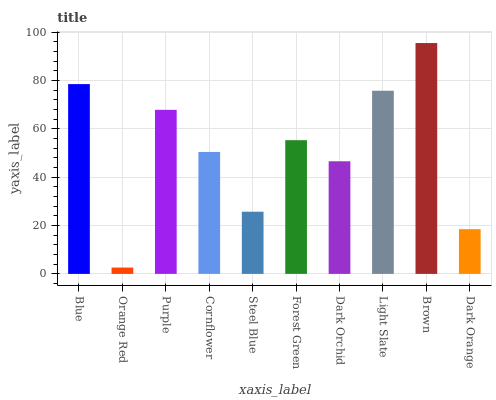Is Orange Red the minimum?
Answer yes or no. Yes. Is Brown the maximum?
Answer yes or no. Yes. Is Purple the minimum?
Answer yes or no. No. Is Purple the maximum?
Answer yes or no. No. Is Purple greater than Orange Red?
Answer yes or no. Yes. Is Orange Red less than Purple?
Answer yes or no. Yes. Is Orange Red greater than Purple?
Answer yes or no. No. Is Purple less than Orange Red?
Answer yes or no. No. Is Forest Green the high median?
Answer yes or no. Yes. Is Cornflower the low median?
Answer yes or no. Yes. Is Dark Orange the high median?
Answer yes or no. No. Is Blue the low median?
Answer yes or no. No. 